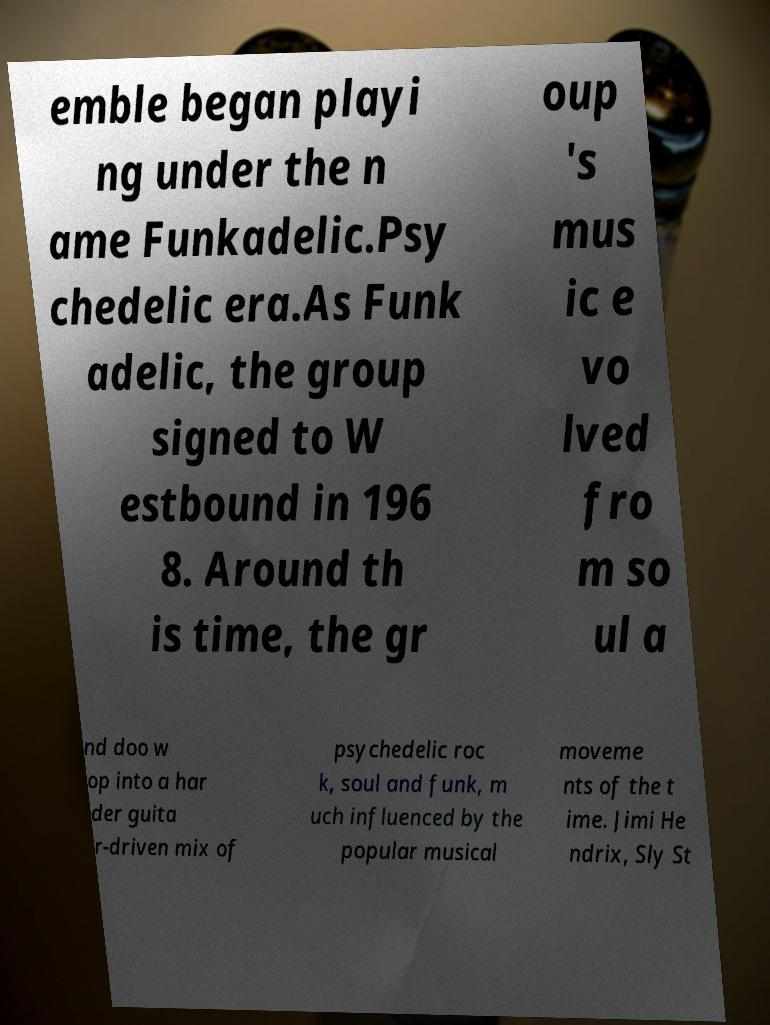Please identify and transcribe the text found in this image. emble began playi ng under the n ame Funkadelic.Psy chedelic era.As Funk adelic, the group signed to W estbound in 196 8. Around th is time, the gr oup 's mus ic e vo lved fro m so ul a nd doo w op into a har der guita r-driven mix of psychedelic roc k, soul and funk, m uch influenced by the popular musical moveme nts of the t ime. Jimi He ndrix, Sly St 